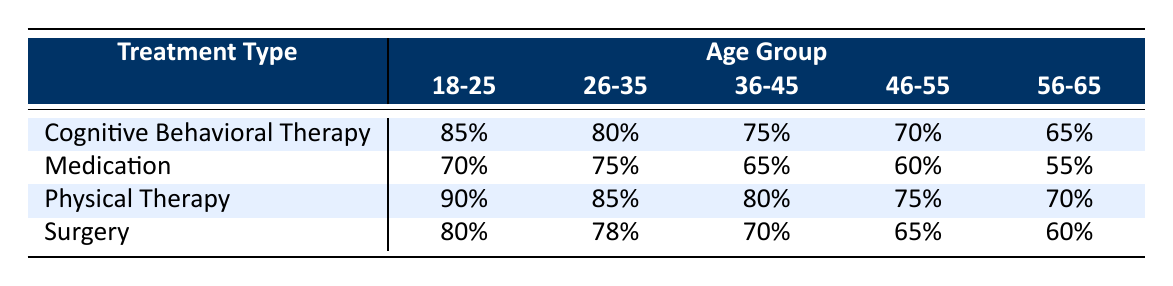What is the Recovery Rate for Physical Therapy in the 36-45 Age Group? From the table, we can directly find the Recovery Rate for Physical Therapy in the 36-45 Age Group, which is listed as 80%.
Answer: 80% Which treatment type has the highest recovery rate for the 26-35 age group? Looking at the 26-35 age group, we find the following recovery rates: Cognitive Behavioral Therapy is 80%, Medication is 75%, Physical Therapy is 85%, and Surgery is 78%. The highest value is from Physical Therapy at 85%.
Answer: Physical Therapy What is the average recovery rate across all treatment types for the 18-25 age group? The recovery rates for the 18-25 age group by treatment type are as follows: 85% (Cognitive Behavioral Therapy), 70% (Medication), 90% (Physical Therapy), and 80% (Surgery). Adding these gives (85 + 70 + 90 + 80) = 325. There are 4 treatment types, so the average is 325 / 4 = 81.25%.
Answer: 81.25% Does Medication have a recovery rate of at least 60% for the 46-55 age group? The recovery rate for Medication in the 46-55 age group is listed as 60%. This meets the criteria of being at least 60%. Therefore, the statement is true.
Answer: Yes Which treatment type shows the largest decline in recovery rates as age increases, specifically from the 18-25 to the 56-65 age group? To analyze the decline in recovery rates, we look at each treatment type: Cognitive Behavioral Therapy declines from 85% to 65% (20%), Medication declines from 70% to 55% (15%), Physical Therapy declines from 90% to 70% (20%), and Surgery declines from 80% to 60% (20%). The largest decline shown by Cognitive Behavioral Therapy, Physical Therapy, and Surgery is 20%.
Answer: Cognitive Behavioral Therapy, Physical Therapy, and Surgery What is the difference in recovery rates between Physical Therapy and Surgery at the 46-55 age group? For Physical Therapy in the 46-55 age group, the recovery rate is 75%, and for Surgery, the rate is 65%. To find the difference, we subtract the Surgery rate from the Physical Therapy rate: 75% - 65% = 10%.
Answer: 10% 